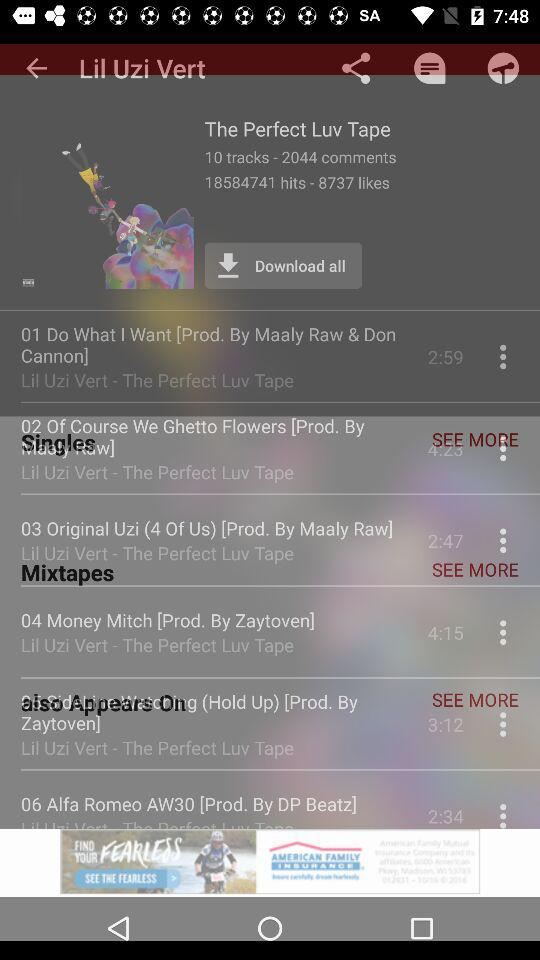How many hits did "The Perfect Luv Tape" get? "The Perfect Luv Tape" got 18584741 hits. 